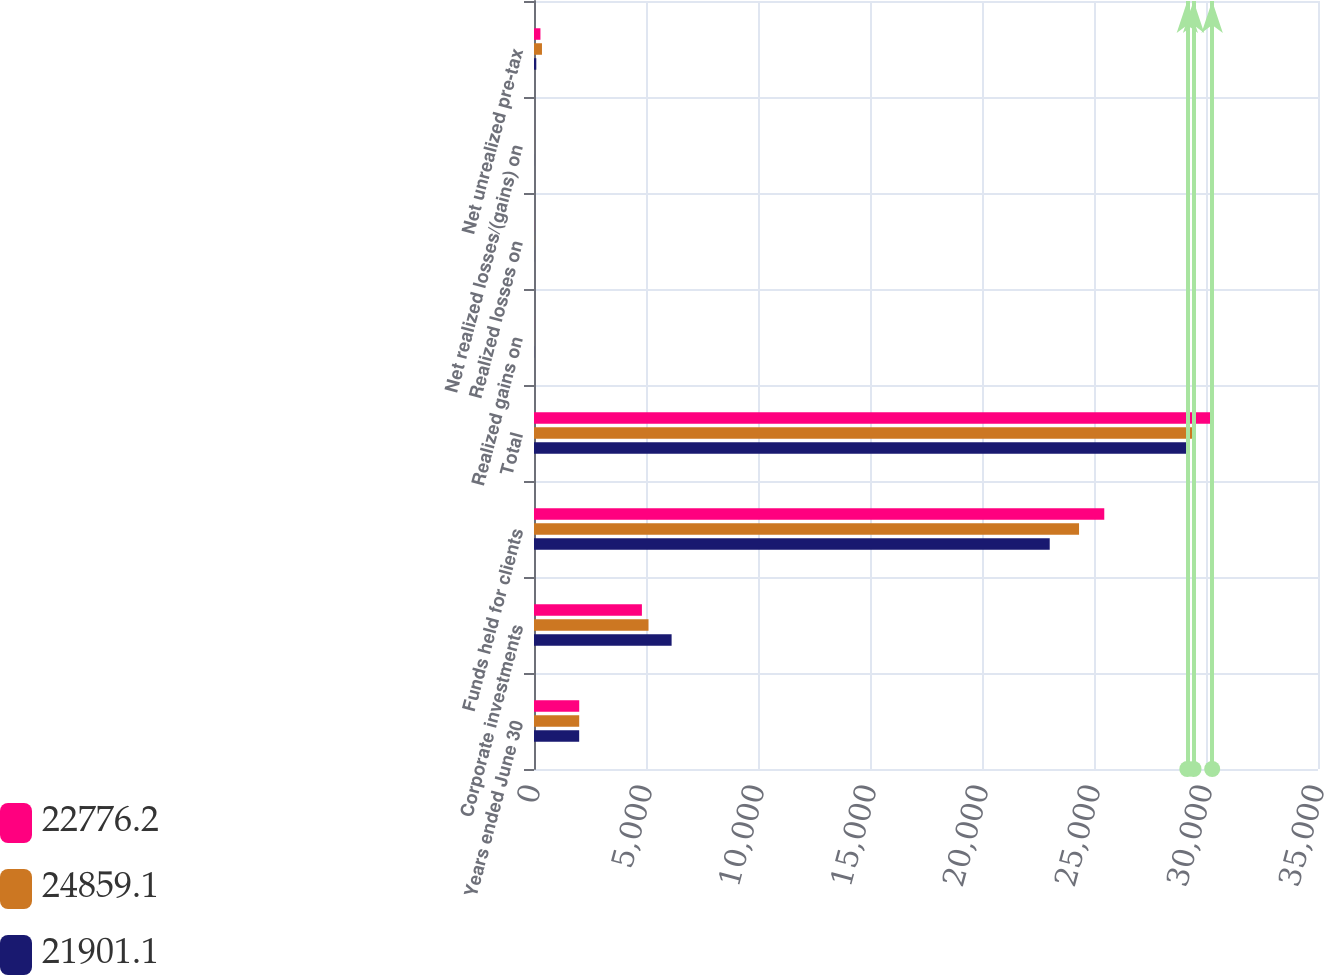Convert chart to OTSL. <chart><loc_0><loc_0><loc_500><loc_500><stacked_bar_chart><ecel><fcel>Years ended June 30<fcel>Corporate investments<fcel>Funds held for clients<fcel>Total<fcel>Realized gains on<fcel>Realized losses on<fcel>Net realized losses/(gains) on<fcel>Net unrealized pre-tax<nl><fcel>22776.2<fcel>2019<fcel>4817.3<fcel>25458.5<fcel>30275.8<fcel>1.8<fcel>2.7<fcel>0.9<fcel>287.5<nl><fcel>24859.1<fcel>2018<fcel>5112.4<fcel>24332.6<fcel>29445<fcel>2<fcel>4.5<fcel>2.5<fcel>355.7<nl><fcel>21901.1<fcel>2017<fcel>6143.3<fcel>23023.5<fcel>29166.8<fcel>5.3<fcel>3.1<fcel>2.2<fcel>102.5<nl></chart> 